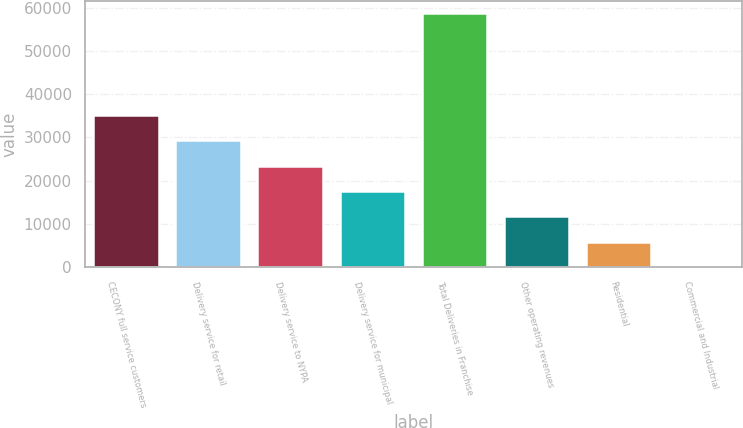Convert chart to OTSL. <chart><loc_0><loc_0><loc_500><loc_500><bar_chart><fcel>CECONY full service customers<fcel>Delivery service for retail<fcel>Delivery service to NYPA<fcel>Delivery service for municipal<fcel>Total Deliveries in Franchise<fcel>Other operating revenues<fcel>Residential<fcel>Commercial and Industrial<nl><fcel>35224<fcel>29356.7<fcel>23489.4<fcel>17622.2<fcel>58693<fcel>11754.9<fcel>5887.66<fcel>20.4<nl></chart> 